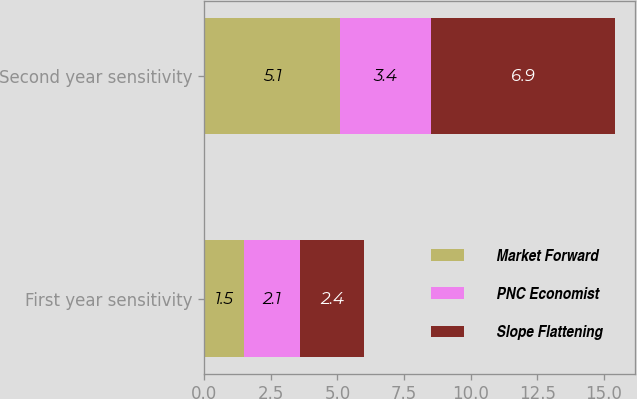<chart> <loc_0><loc_0><loc_500><loc_500><stacked_bar_chart><ecel><fcel>First year sensitivity<fcel>Second year sensitivity<nl><fcel>Market Forward<fcel>1.5<fcel>5.1<nl><fcel>PNC Economist<fcel>2.1<fcel>3.4<nl><fcel>Slope Flattening<fcel>2.4<fcel>6.9<nl></chart> 